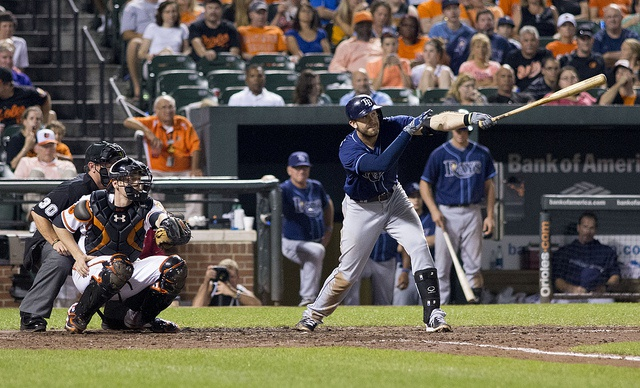Describe the objects in this image and their specific colors. I can see people in black, gray, and navy tones, people in black, gray, white, and maroon tones, people in black, lightgray, gray, and navy tones, people in black, navy, gray, and darkgray tones, and people in black, gray, tan, and lightgray tones in this image. 